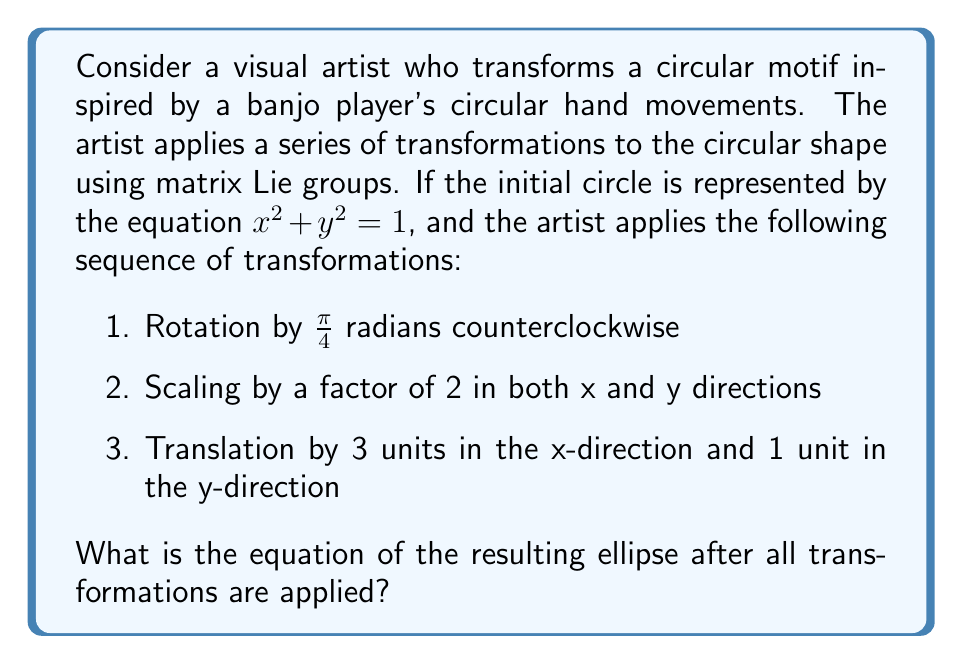Solve this math problem. Let's approach this step-by-step using matrix Lie groups:

1) First, we need to represent each transformation as a matrix in the special Euclidean group SE(2):

   Rotation by $\frac{\pi}{4}$:
   $$R = \begin{pmatrix} 
   \cos(\frac{\pi}{4}) & -\sin(\frac{\pi}{4}) & 0 \\
   \sin(\frac{\pi}{4}) & \cos(\frac{\pi}{4}) & 0 \\
   0 & 0 & 1
   \end{pmatrix} = \begin{pmatrix} 
   \frac{\sqrt{2}}{2} & -\frac{\sqrt{2}}{2} & 0 \\
   \frac{\sqrt{2}}{2} & \frac{\sqrt{2}}{2} & 0 \\
   0 & 0 & 1
   \end{pmatrix}$$

   Scaling by 2:
   $$S = \begin{pmatrix} 
   2 & 0 & 0 \\
   0 & 2 & 0 \\
   0 & 0 & 1
   \end{pmatrix}$$

   Translation by (3,1):
   $$T = \begin{pmatrix} 
   1 & 0 & 3 \\
   0 & 1 & 1 \\
   0 & 0 & 1
   \end{pmatrix}$$

2) The combined transformation matrix is the product of these matrices in reverse order:
   $$M = T \cdot S \cdot R = \begin{pmatrix} 
   2\sqrt{2} & -2\sqrt{2} & 3 \\
   2\sqrt{2} & 2\sqrt{2} & 1 \\
   0 & 0 & 1
   \end{pmatrix}$$

3) To find the equation of the transformed ellipse, we need to apply the inverse of this transformation to the general point (x,y,1) and substitute it into the original circle equation:

   $$M^{-1} = \begin{pmatrix} 
   \frac{\sqrt{2}}{4} & \frac{\sqrt{2}}{4} & -\frac{3\sqrt{2}}{4}-\frac{1}{4} \\
   -\frac{\sqrt{2}}{4} & \frac{\sqrt{2}}{4} & \frac{3\sqrt{2}}{4}-\frac{1}{4} \\
   0 & 0 & 1
   \end{pmatrix}$$

4) Applying this to (x,y,1) gives:
   $$\begin{pmatrix} 
   \frac{\sqrt{2}}{4}(x-3) + \frac{\sqrt{2}}{4}(y-1) \\
   -\frac{\sqrt{2}}{4}(x-3) + \frac{\sqrt{2}}{4}(y-1) \\
   1
   \end{pmatrix}$$

5) Substituting these into $x^2 + y^2 = 1$ gives:
   $$(\frac{\sqrt{2}}{4}(x-3) + \frac{\sqrt{2}}{4}(y-1))^2 + (-\frac{\sqrt{2}}{4}(x-3) + \frac{\sqrt{2}}{4}(y-1))^2 = 1$$

6) Simplifying this equation results in:
   $$\frac{(x-3)^2}{4} + \frac{(y-1)^2}{4} = 1$$

This is the equation of the transformed ellipse.
Answer: The equation of the resulting ellipse after all transformations are applied is:

$$\frac{(x-3)^2}{4} + \frac{(y-1)^2}{4} = 1$$ 